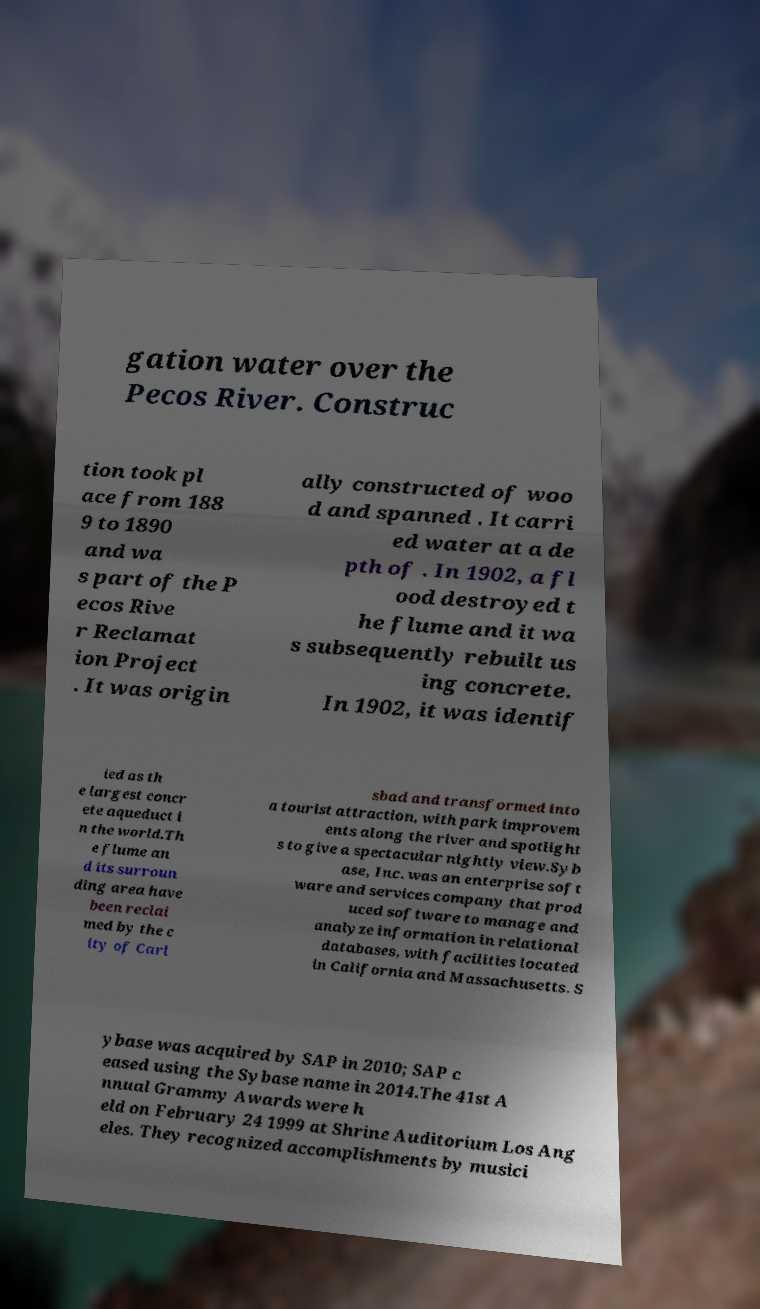There's text embedded in this image that I need extracted. Can you transcribe it verbatim? gation water over the Pecos River. Construc tion took pl ace from 188 9 to 1890 and wa s part of the P ecos Rive r Reclamat ion Project . It was origin ally constructed of woo d and spanned . It carri ed water at a de pth of . In 1902, a fl ood destroyed t he flume and it wa s subsequently rebuilt us ing concrete. In 1902, it was identif ied as th e largest concr ete aqueduct i n the world.Th e flume an d its surroun ding area have been reclai med by the c ity of Carl sbad and transformed into a tourist attraction, with park improvem ents along the river and spotlight s to give a spectacular nightly view.Syb ase, Inc. was an enterprise soft ware and services company that prod uced software to manage and analyze information in relational databases, with facilities located in California and Massachusetts. S ybase was acquired by SAP in 2010; SAP c eased using the Sybase name in 2014.The 41st A nnual Grammy Awards were h eld on February 24 1999 at Shrine Auditorium Los Ang eles. They recognized accomplishments by musici 